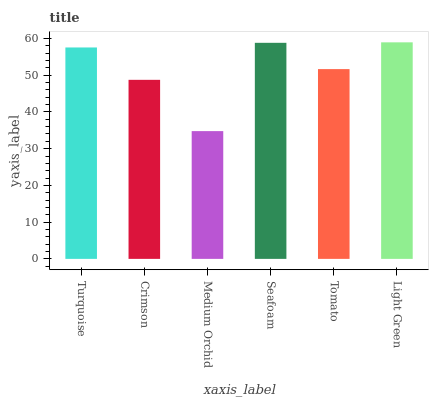Is Medium Orchid the minimum?
Answer yes or no. Yes. Is Light Green the maximum?
Answer yes or no. Yes. Is Crimson the minimum?
Answer yes or no. No. Is Crimson the maximum?
Answer yes or no. No. Is Turquoise greater than Crimson?
Answer yes or no. Yes. Is Crimson less than Turquoise?
Answer yes or no. Yes. Is Crimson greater than Turquoise?
Answer yes or no. No. Is Turquoise less than Crimson?
Answer yes or no. No. Is Turquoise the high median?
Answer yes or no. Yes. Is Tomato the low median?
Answer yes or no. Yes. Is Medium Orchid the high median?
Answer yes or no. No. Is Light Green the low median?
Answer yes or no. No. 